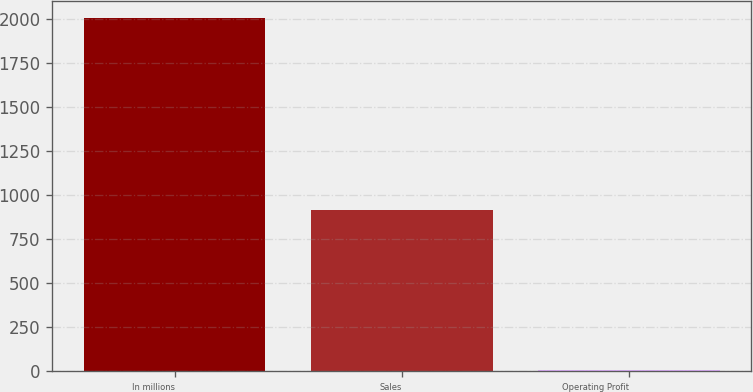Convert chart to OTSL. <chart><loc_0><loc_0><loc_500><loc_500><bar_chart><fcel>In millions<fcel>Sales<fcel>Operating Profit<nl><fcel>2005<fcel>915<fcel>4<nl></chart> 